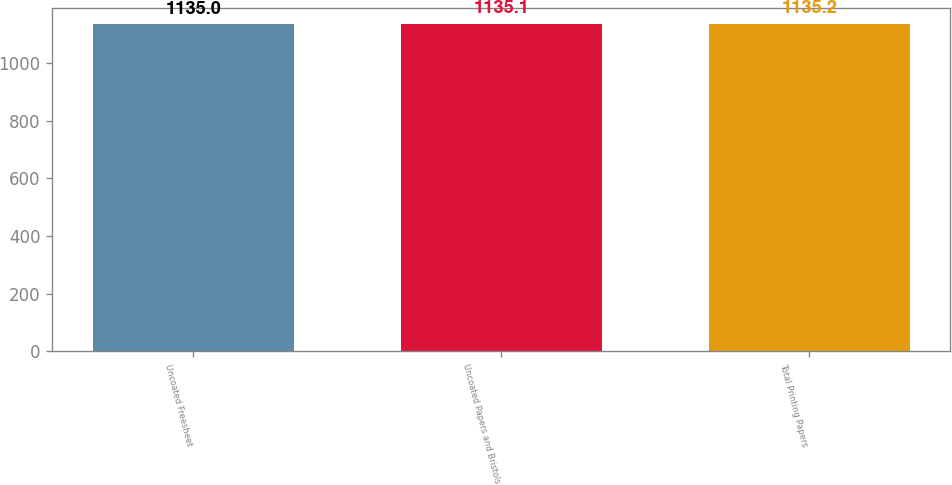Convert chart to OTSL. <chart><loc_0><loc_0><loc_500><loc_500><bar_chart><fcel>Uncoated Freesheet<fcel>Uncoated Papers and Bristols<fcel>Total Printing Papers<nl><fcel>1135<fcel>1135.1<fcel>1135.2<nl></chart> 